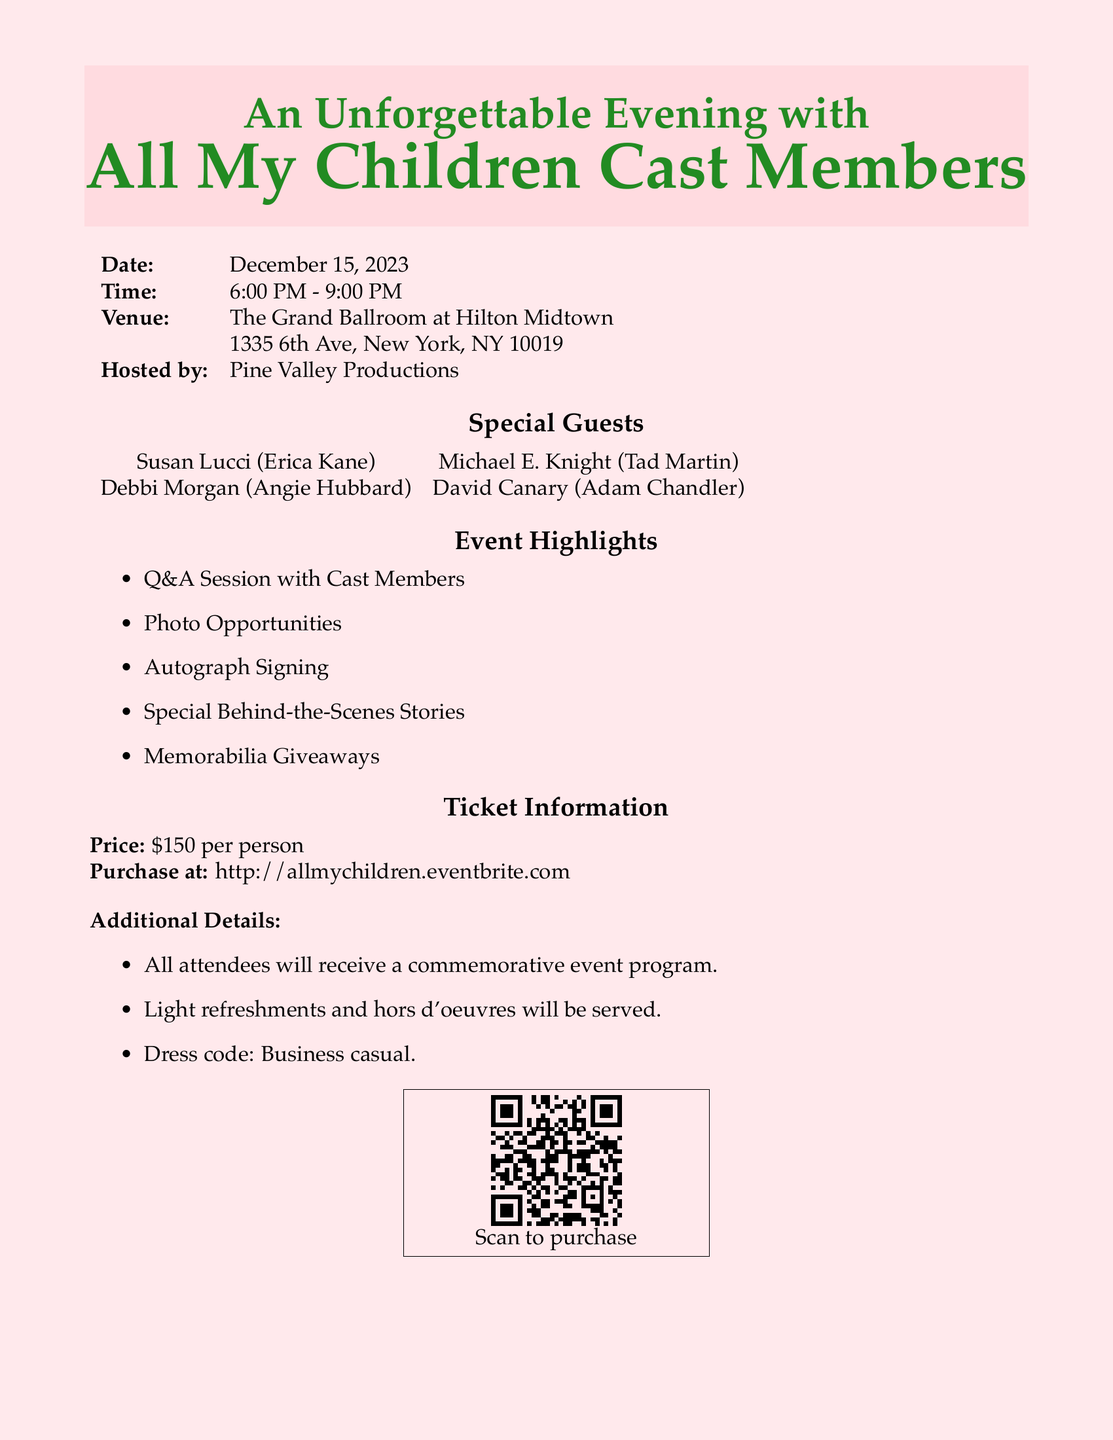what is the date of the event? The date is specified clearly in the document as December 15, 2023.
Answer: December 15, 2023 what is the venue for the event? The venue is given as The Grand Ballroom at Hilton Midtown.
Answer: The Grand Ballroom at Hilton Midtown who is hosting the event? The document states that the event is hosted by Pine Valley Productions.
Answer: Pine Valley Productions what time does the event start? The starting time of the event is mentioned as 6:00 PM.
Answer: 6:00 PM how much does a ticket cost? The ticket information specifies the price is $150 per person.
Answer: $150 per person name one of the special guests attending. One of the special guests listed is Susan Lucci.
Answer: Susan Lucci what will attendees receive at the event? The additional details confirm that attendees will receive a commemorative event program.
Answer: a commemorative event program what type of refreshments will be served? The document notes that light refreshments and hors d'oeuvres will be served at the event.
Answer: Light refreshments and hors d'oeuvres what activity involves the cast members? The event features a Q&A Session with the cast members for attendee engagement.
Answer: Q&A Session 